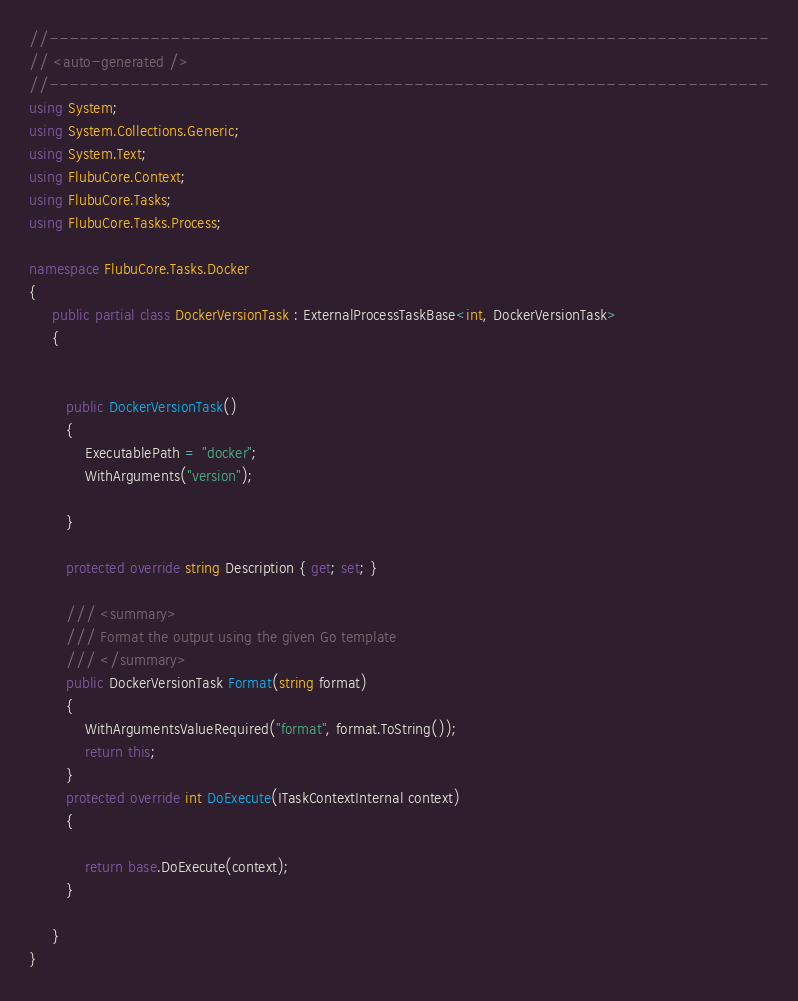<code> <loc_0><loc_0><loc_500><loc_500><_C#_>
//-----------------------------------------------------------------------
// <auto-generated />
//-----------------------------------------------------------------------
using System;
using System.Collections.Generic;
using System.Text;
using FlubuCore.Context;
using FlubuCore.Tasks;
using FlubuCore.Tasks.Process;

namespace FlubuCore.Tasks.Docker
{
     public partial class DockerVersionTask : ExternalProcessTaskBase<int, DockerVersionTask>
     {
        
        
        public DockerVersionTask()
        {
            ExecutablePath = "docker";
            WithArguments("version");

        }

        protected override string Description { get; set; }
        
        /// <summary>
        /// Format the output using the given Go template
        /// </summary>
        public DockerVersionTask Format(string format)
        {
            WithArgumentsValueRequired("format", format.ToString());
            return this;
        }
        protected override int DoExecute(ITaskContextInternal context)
        {
            
            return base.DoExecute(context);
        }

     }
}
</code> 